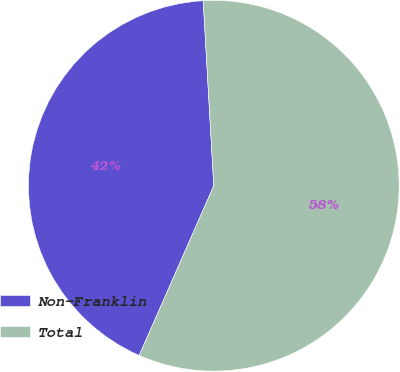Convert chart to OTSL. <chart><loc_0><loc_0><loc_500><loc_500><pie_chart><fcel>Non-Franklin<fcel>Total<nl><fcel>42.5%<fcel>57.5%<nl></chart> 